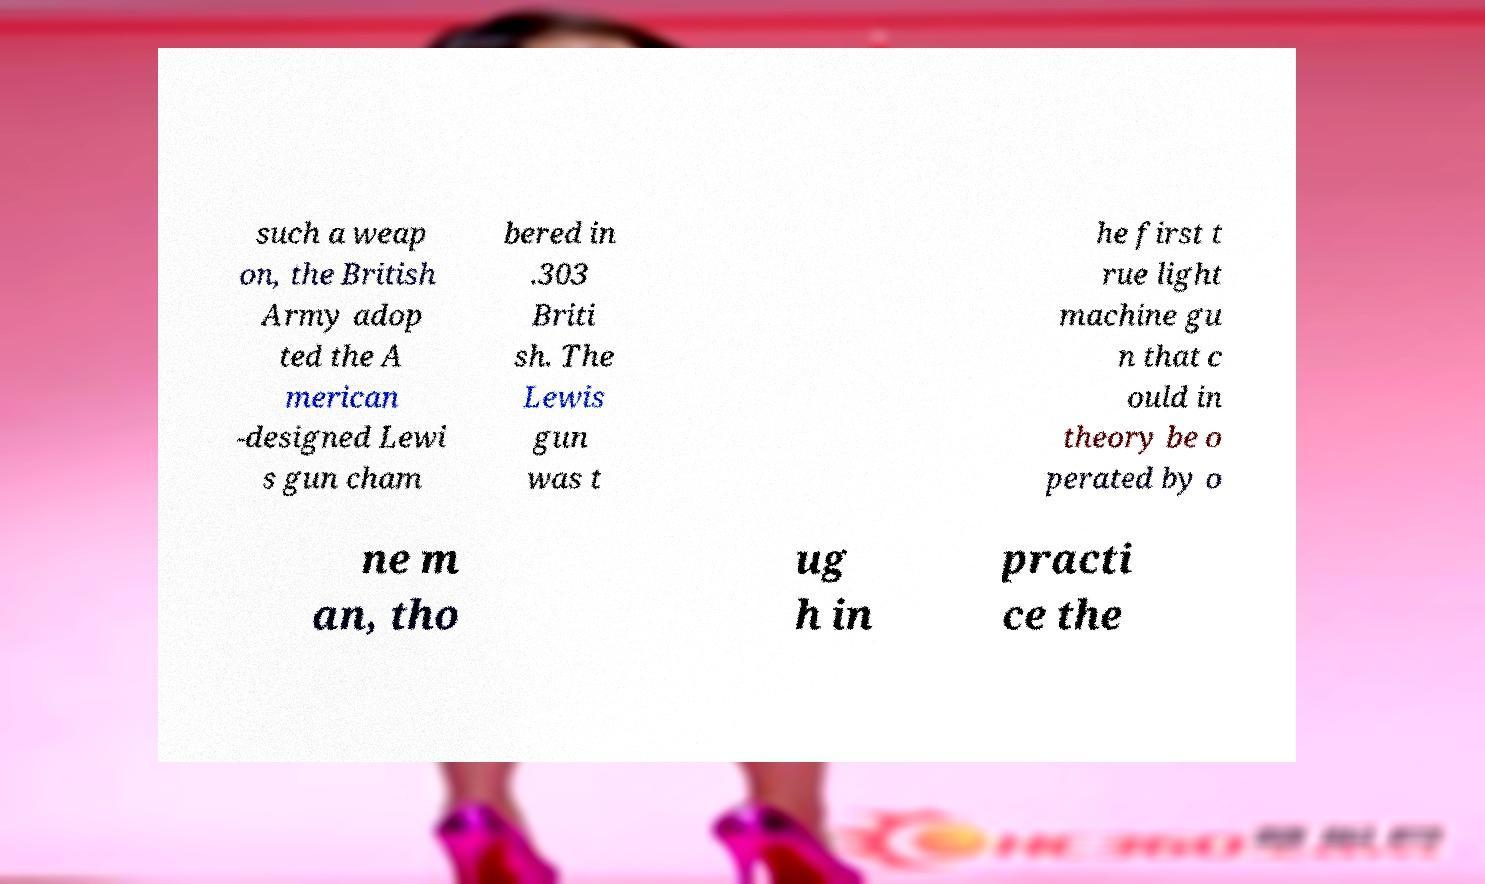For documentation purposes, I need the text within this image transcribed. Could you provide that? such a weap on, the British Army adop ted the A merican -designed Lewi s gun cham bered in .303 Briti sh. The Lewis gun was t he first t rue light machine gu n that c ould in theory be o perated by o ne m an, tho ug h in practi ce the 